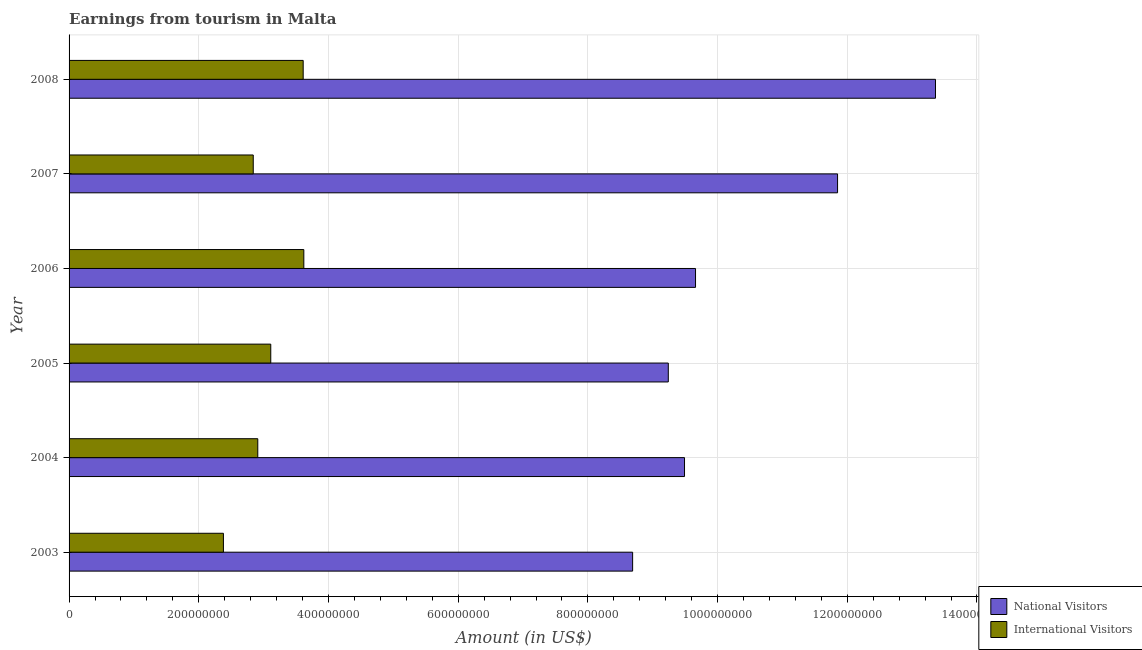How many different coloured bars are there?
Make the answer very short. 2. Are the number of bars on each tick of the Y-axis equal?
Make the answer very short. Yes. What is the label of the 3rd group of bars from the top?
Keep it short and to the point. 2006. In how many cases, is the number of bars for a given year not equal to the number of legend labels?
Offer a terse response. 0. What is the amount earned from international visitors in 2004?
Offer a very short reply. 2.91e+08. Across all years, what is the maximum amount earned from international visitors?
Keep it short and to the point. 3.62e+08. Across all years, what is the minimum amount earned from international visitors?
Offer a very short reply. 2.38e+08. What is the total amount earned from national visitors in the graph?
Your answer should be very brief. 6.23e+09. What is the difference between the amount earned from international visitors in 2006 and that in 2007?
Offer a terse response. 7.80e+07. What is the difference between the amount earned from international visitors in 2003 and the amount earned from national visitors in 2007?
Provide a short and direct response. -9.47e+08. What is the average amount earned from international visitors per year?
Your response must be concise. 3.08e+08. In the year 2008, what is the difference between the amount earned from international visitors and amount earned from national visitors?
Your response must be concise. -9.75e+08. What is the ratio of the amount earned from national visitors in 2005 to that in 2008?
Provide a short and direct response. 0.69. What is the difference between the highest and the second highest amount earned from international visitors?
Give a very brief answer. 1.00e+06. What is the difference between the highest and the lowest amount earned from national visitors?
Make the answer very short. 4.67e+08. Is the sum of the amount earned from international visitors in 2006 and 2008 greater than the maximum amount earned from national visitors across all years?
Your answer should be very brief. No. What does the 2nd bar from the top in 2006 represents?
Offer a terse response. National Visitors. What does the 1st bar from the bottom in 2008 represents?
Provide a succinct answer. National Visitors. How many bars are there?
Give a very brief answer. 12. Are all the bars in the graph horizontal?
Offer a very short reply. Yes. What is the difference between two consecutive major ticks on the X-axis?
Your answer should be very brief. 2.00e+08. Are the values on the major ticks of X-axis written in scientific E-notation?
Make the answer very short. No. Does the graph contain any zero values?
Your response must be concise. No. Does the graph contain grids?
Offer a terse response. Yes. How are the legend labels stacked?
Keep it short and to the point. Vertical. What is the title of the graph?
Offer a very short reply. Earnings from tourism in Malta. Does "Forest" appear as one of the legend labels in the graph?
Offer a very short reply. No. What is the label or title of the X-axis?
Ensure brevity in your answer.  Amount (in US$). What is the label or title of the Y-axis?
Your response must be concise. Year. What is the Amount (in US$) in National Visitors in 2003?
Keep it short and to the point. 8.69e+08. What is the Amount (in US$) in International Visitors in 2003?
Make the answer very short. 2.38e+08. What is the Amount (in US$) of National Visitors in 2004?
Your response must be concise. 9.49e+08. What is the Amount (in US$) in International Visitors in 2004?
Provide a short and direct response. 2.91e+08. What is the Amount (in US$) of National Visitors in 2005?
Your answer should be very brief. 9.24e+08. What is the Amount (in US$) in International Visitors in 2005?
Offer a very short reply. 3.11e+08. What is the Amount (in US$) of National Visitors in 2006?
Give a very brief answer. 9.66e+08. What is the Amount (in US$) of International Visitors in 2006?
Provide a succinct answer. 3.62e+08. What is the Amount (in US$) in National Visitors in 2007?
Ensure brevity in your answer.  1.18e+09. What is the Amount (in US$) in International Visitors in 2007?
Your answer should be very brief. 2.84e+08. What is the Amount (in US$) in National Visitors in 2008?
Provide a succinct answer. 1.34e+09. What is the Amount (in US$) in International Visitors in 2008?
Ensure brevity in your answer.  3.61e+08. Across all years, what is the maximum Amount (in US$) in National Visitors?
Give a very brief answer. 1.34e+09. Across all years, what is the maximum Amount (in US$) of International Visitors?
Keep it short and to the point. 3.62e+08. Across all years, what is the minimum Amount (in US$) in National Visitors?
Offer a terse response. 8.69e+08. Across all years, what is the minimum Amount (in US$) in International Visitors?
Provide a succinct answer. 2.38e+08. What is the total Amount (in US$) in National Visitors in the graph?
Offer a very short reply. 6.23e+09. What is the total Amount (in US$) of International Visitors in the graph?
Ensure brevity in your answer.  1.85e+09. What is the difference between the Amount (in US$) of National Visitors in 2003 and that in 2004?
Offer a terse response. -8.00e+07. What is the difference between the Amount (in US$) of International Visitors in 2003 and that in 2004?
Give a very brief answer. -5.30e+07. What is the difference between the Amount (in US$) in National Visitors in 2003 and that in 2005?
Give a very brief answer. -5.50e+07. What is the difference between the Amount (in US$) of International Visitors in 2003 and that in 2005?
Your response must be concise. -7.30e+07. What is the difference between the Amount (in US$) of National Visitors in 2003 and that in 2006?
Provide a short and direct response. -9.70e+07. What is the difference between the Amount (in US$) in International Visitors in 2003 and that in 2006?
Give a very brief answer. -1.24e+08. What is the difference between the Amount (in US$) of National Visitors in 2003 and that in 2007?
Provide a succinct answer. -3.16e+08. What is the difference between the Amount (in US$) in International Visitors in 2003 and that in 2007?
Provide a succinct answer. -4.60e+07. What is the difference between the Amount (in US$) in National Visitors in 2003 and that in 2008?
Offer a terse response. -4.67e+08. What is the difference between the Amount (in US$) in International Visitors in 2003 and that in 2008?
Offer a terse response. -1.23e+08. What is the difference between the Amount (in US$) of National Visitors in 2004 and that in 2005?
Your response must be concise. 2.50e+07. What is the difference between the Amount (in US$) in International Visitors in 2004 and that in 2005?
Provide a succinct answer. -2.00e+07. What is the difference between the Amount (in US$) in National Visitors in 2004 and that in 2006?
Ensure brevity in your answer.  -1.70e+07. What is the difference between the Amount (in US$) in International Visitors in 2004 and that in 2006?
Make the answer very short. -7.10e+07. What is the difference between the Amount (in US$) of National Visitors in 2004 and that in 2007?
Give a very brief answer. -2.36e+08. What is the difference between the Amount (in US$) of National Visitors in 2004 and that in 2008?
Give a very brief answer. -3.87e+08. What is the difference between the Amount (in US$) of International Visitors in 2004 and that in 2008?
Your response must be concise. -7.00e+07. What is the difference between the Amount (in US$) in National Visitors in 2005 and that in 2006?
Your answer should be very brief. -4.20e+07. What is the difference between the Amount (in US$) in International Visitors in 2005 and that in 2006?
Your answer should be compact. -5.10e+07. What is the difference between the Amount (in US$) of National Visitors in 2005 and that in 2007?
Make the answer very short. -2.61e+08. What is the difference between the Amount (in US$) in International Visitors in 2005 and that in 2007?
Your response must be concise. 2.70e+07. What is the difference between the Amount (in US$) in National Visitors in 2005 and that in 2008?
Offer a very short reply. -4.12e+08. What is the difference between the Amount (in US$) in International Visitors in 2005 and that in 2008?
Ensure brevity in your answer.  -5.00e+07. What is the difference between the Amount (in US$) in National Visitors in 2006 and that in 2007?
Keep it short and to the point. -2.19e+08. What is the difference between the Amount (in US$) of International Visitors in 2006 and that in 2007?
Keep it short and to the point. 7.80e+07. What is the difference between the Amount (in US$) in National Visitors in 2006 and that in 2008?
Offer a terse response. -3.70e+08. What is the difference between the Amount (in US$) in International Visitors in 2006 and that in 2008?
Your answer should be compact. 1.00e+06. What is the difference between the Amount (in US$) in National Visitors in 2007 and that in 2008?
Keep it short and to the point. -1.51e+08. What is the difference between the Amount (in US$) in International Visitors in 2007 and that in 2008?
Your answer should be compact. -7.70e+07. What is the difference between the Amount (in US$) of National Visitors in 2003 and the Amount (in US$) of International Visitors in 2004?
Your answer should be very brief. 5.78e+08. What is the difference between the Amount (in US$) in National Visitors in 2003 and the Amount (in US$) in International Visitors in 2005?
Your answer should be compact. 5.58e+08. What is the difference between the Amount (in US$) of National Visitors in 2003 and the Amount (in US$) of International Visitors in 2006?
Offer a terse response. 5.07e+08. What is the difference between the Amount (in US$) in National Visitors in 2003 and the Amount (in US$) in International Visitors in 2007?
Offer a terse response. 5.85e+08. What is the difference between the Amount (in US$) in National Visitors in 2003 and the Amount (in US$) in International Visitors in 2008?
Ensure brevity in your answer.  5.08e+08. What is the difference between the Amount (in US$) of National Visitors in 2004 and the Amount (in US$) of International Visitors in 2005?
Make the answer very short. 6.38e+08. What is the difference between the Amount (in US$) of National Visitors in 2004 and the Amount (in US$) of International Visitors in 2006?
Provide a short and direct response. 5.87e+08. What is the difference between the Amount (in US$) in National Visitors in 2004 and the Amount (in US$) in International Visitors in 2007?
Give a very brief answer. 6.65e+08. What is the difference between the Amount (in US$) in National Visitors in 2004 and the Amount (in US$) in International Visitors in 2008?
Your answer should be very brief. 5.88e+08. What is the difference between the Amount (in US$) in National Visitors in 2005 and the Amount (in US$) in International Visitors in 2006?
Offer a terse response. 5.62e+08. What is the difference between the Amount (in US$) of National Visitors in 2005 and the Amount (in US$) of International Visitors in 2007?
Your answer should be very brief. 6.40e+08. What is the difference between the Amount (in US$) in National Visitors in 2005 and the Amount (in US$) in International Visitors in 2008?
Your answer should be compact. 5.63e+08. What is the difference between the Amount (in US$) in National Visitors in 2006 and the Amount (in US$) in International Visitors in 2007?
Make the answer very short. 6.82e+08. What is the difference between the Amount (in US$) of National Visitors in 2006 and the Amount (in US$) of International Visitors in 2008?
Keep it short and to the point. 6.05e+08. What is the difference between the Amount (in US$) in National Visitors in 2007 and the Amount (in US$) in International Visitors in 2008?
Keep it short and to the point. 8.24e+08. What is the average Amount (in US$) of National Visitors per year?
Your answer should be compact. 1.04e+09. What is the average Amount (in US$) in International Visitors per year?
Your answer should be very brief. 3.08e+08. In the year 2003, what is the difference between the Amount (in US$) in National Visitors and Amount (in US$) in International Visitors?
Give a very brief answer. 6.31e+08. In the year 2004, what is the difference between the Amount (in US$) of National Visitors and Amount (in US$) of International Visitors?
Your answer should be compact. 6.58e+08. In the year 2005, what is the difference between the Amount (in US$) in National Visitors and Amount (in US$) in International Visitors?
Provide a short and direct response. 6.13e+08. In the year 2006, what is the difference between the Amount (in US$) of National Visitors and Amount (in US$) of International Visitors?
Provide a succinct answer. 6.04e+08. In the year 2007, what is the difference between the Amount (in US$) of National Visitors and Amount (in US$) of International Visitors?
Your answer should be very brief. 9.01e+08. In the year 2008, what is the difference between the Amount (in US$) in National Visitors and Amount (in US$) in International Visitors?
Your answer should be very brief. 9.75e+08. What is the ratio of the Amount (in US$) in National Visitors in 2003 to that in 2004?
Provide a short and direct response. 0.92. What is the ratio of the Amount (in US$) in International Visitors in 2003 to that in 2004?
Your answer should be compact. 0.82. What is the ratio of the Amount (in US$) of National Visitors in 2003 to that in 2005?
Offer a very short reply. 0.94. What is the ratio of the Amount (in US$) of International Visitors in 2003 to that in 2005?
Keep it short and to the point. 0.77. What is the ratio of the Amount (in US$) in National Visitors in 2003 to that in 2006?
Provide a succinct answer. 0.9. What is the ratio of the Amount (in US$) of International Visitors in 2003 to that in 2006?
Your answer should be compact. 0.66. What is the ratio of the Amount (in US$) in National Visitors in 2003 to that in 2007?
Your answer should be very brief. 0.73. What is the ratio of the Amount (in US$) in International Visitors in 2003 to that in 2007?
Your response must be concise. 0.84. What is the ratio of the Amount (in US$) in National Visitors in 2003 to that in 2008?
Your answer should be compact. 0.65. What is the ratio of the Amount (in US$) of International Visitors in 2003 to that in 2008?
Your answer should be very brief. 0.66. What is the ratio of the Amount (in US$) in National Visitors in 2004 to that in 2005?
Make the answer very short. 1.03. What is the ratio of the Amount (in US$) of International Visitors in 2004 to that in 2005?
Your answer should be compact. 0.94. What is the ratio of the Amount (in US$) of National Visitors in 2004 to that in 2006?
Ensure brevity in your answer.  0.98. What is the ratio of the Amount (in US$) in International Visitors in 2004 to that in 2006?
Ensure brevity in your answer.  0.8. What is the ratio of the Amount (in US$) in National Visitors in 2004 to that in 2007?
Your answer should be compact. 0.8. What is the ratio of the Amount (in US$) in International Visitors in 2004 to that in 2007?
Offer a very short reply. 1.02. What is the ratio of the Amount (in US$) in National Visitors in 2004 to that in 2008?
Your answer should be very brief. 0.71. What is the ratio of the Amount (in US$) in International Visitors in 2004 to that in 2008?
Make the answer very short. 0.81. What is the ratio of the Amount (in US$) of National Visitors in 2005 to that in 2006?
Offer a very short reply. 0.96. What is the ratio of the Amount (in US$) in International Visitors in 2005 to that in 2006?
Your response must be concise. 0.86. What is the ratio of the Amount (in US$) in National Visitors in 2005 to that in 2007?
Make the answer very short. 0.78. What is the ratio of the Amount (in US$) of International Visitors in 2005 to that in 2007?
Your response must be concise. 1.1. What is the ratio of the Amount (in US$) of National Visitors in 2005 to that in 2008?
Your answer should be compact. 0.69. What is the ratio of the Amount (in US$) in International Visitors in 2005 to that in 2008?
Your answer should be compact. 0.86. What is the ratio of the Amount (in US$) in National Visitors in 2006 to that in 2007?
Provide a succinct answer. 0.82. What is the ratio of the Amount (in US$) in International Visitors in 2006 to that in 2007?
Your answer should be very brief. 1.27. What is the ratio of the Amount (in US$) of National Visitors in 2006 to that in 2008?
Give a very brief answer. 0.72. What is the ratio of the Amount (in US$) in International Visitors in 2006 to that in 2008?
Make the answer very short. 1. What is the ratio of the Amount (in US$) in National Visitors in 2007 to that in 2008?
Your response must be concise. 0.89. What is the ratio of the Amount (in US$) in International Visitors in 2007 to that in 2008?
Keep it short and to the point. 0.79. What is the difference between the highest and the second highest Amount (in US$) in National Visitors?
Make the answer very short. 1.51e+08. What is the difference between the highest and the lowest Amount (in US$) of National Visitors?
Offer a very short reply. 4.67e+08. What is the difference between the highest and the lowest Amount (in US$) of International Visitors?
Your answer should be compact. 1.24e+08. 